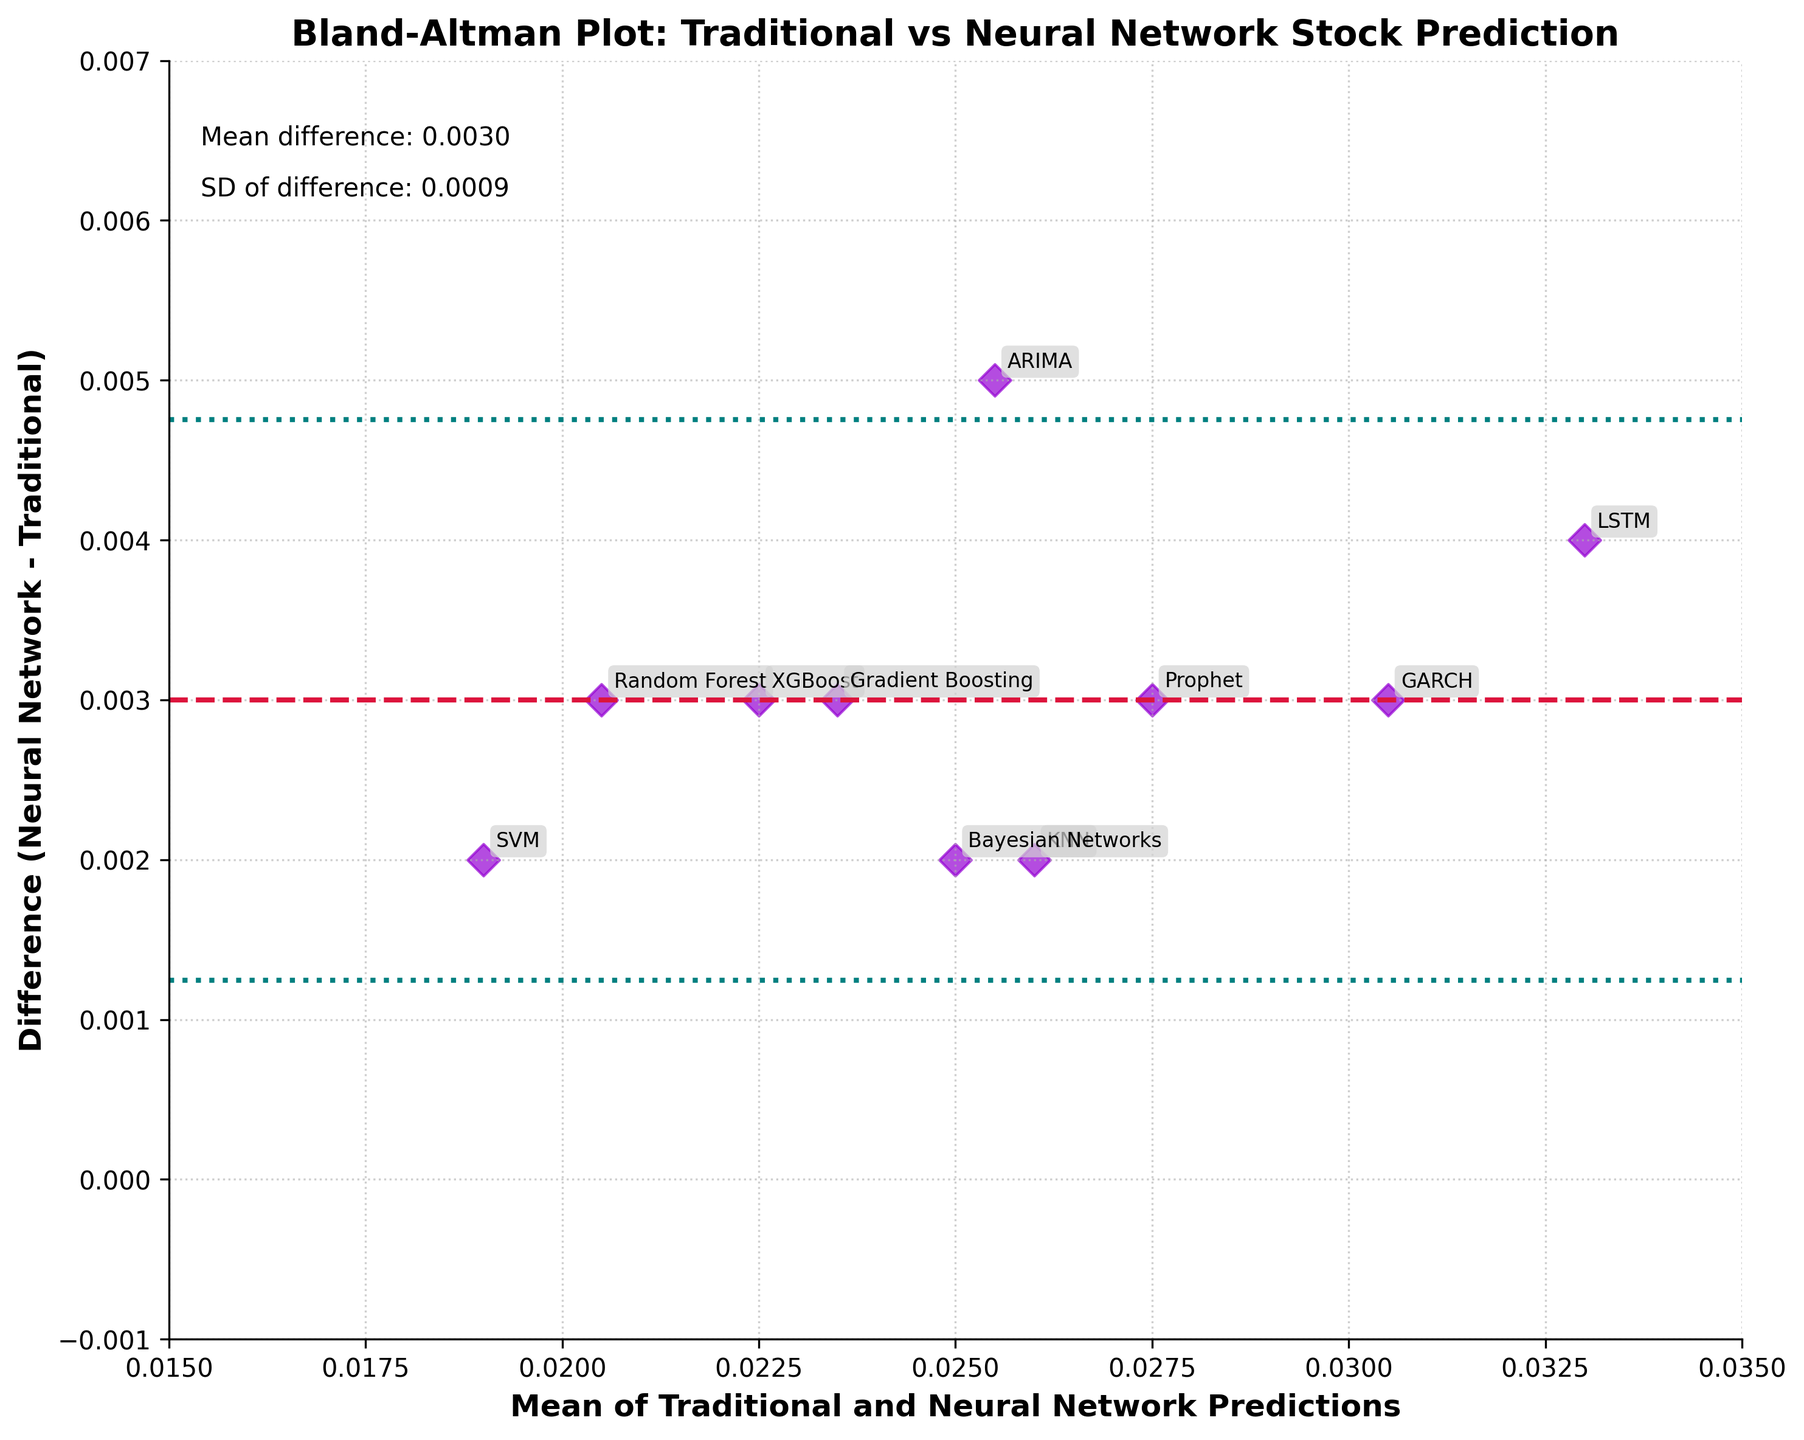What's the title of the figure? The title of the figure is located at the top center of the plot.
Answer: Bland-Altman Plot: Traditional vs Neural Network Stock Prediction How many data points are shown in the plot? Count the number of scatter points or annotations on the plot.
Answer: 10 What's the mean difference shown in the plot? The mean difference is indicated by a horizontal dashed line and is labeled on the plot.
Answer: 0.0042 Which method has the highest difference (Neural Network - Traditional)? Look for the point with the maximum y-coordinate value. The annotations display the methods.
Answer: GARCH What's the difference value for the Random Forest method? Find the point corresponding to the Random Forest method and read the y-coordinate value.
Answer: 0.003 What's the most common color used for the scatter points in the plot? Observe the color of the majority of scatter points in the plot.
Answer: Darkviolet What are the upper and lower limits of agreement depicted on the plot? The upper and lower limits are marked by dotted lines and specified as ±1.96 * SD from the mean difference.
Answer: 0.0112, -0.0028 What's the average of the predictions for the ARIMA and LSTM methods? Look at the x-coordinates for ARIMA and LSTM, which represent the means of predictions for these methods, and average them. ((0.0255 + 0.033)/2)
Answer: 0.0292 Which method lies closest to the mean difference line? Identify the point closest to the dashed mean difference line at 0.0042.
Answer: KNN How are the differences generally distributed around the mean difference line? Observe the spread of the points above and below the mean difference line to determine if they are evenly distributed.
Answer: Fairly evenly distributed 